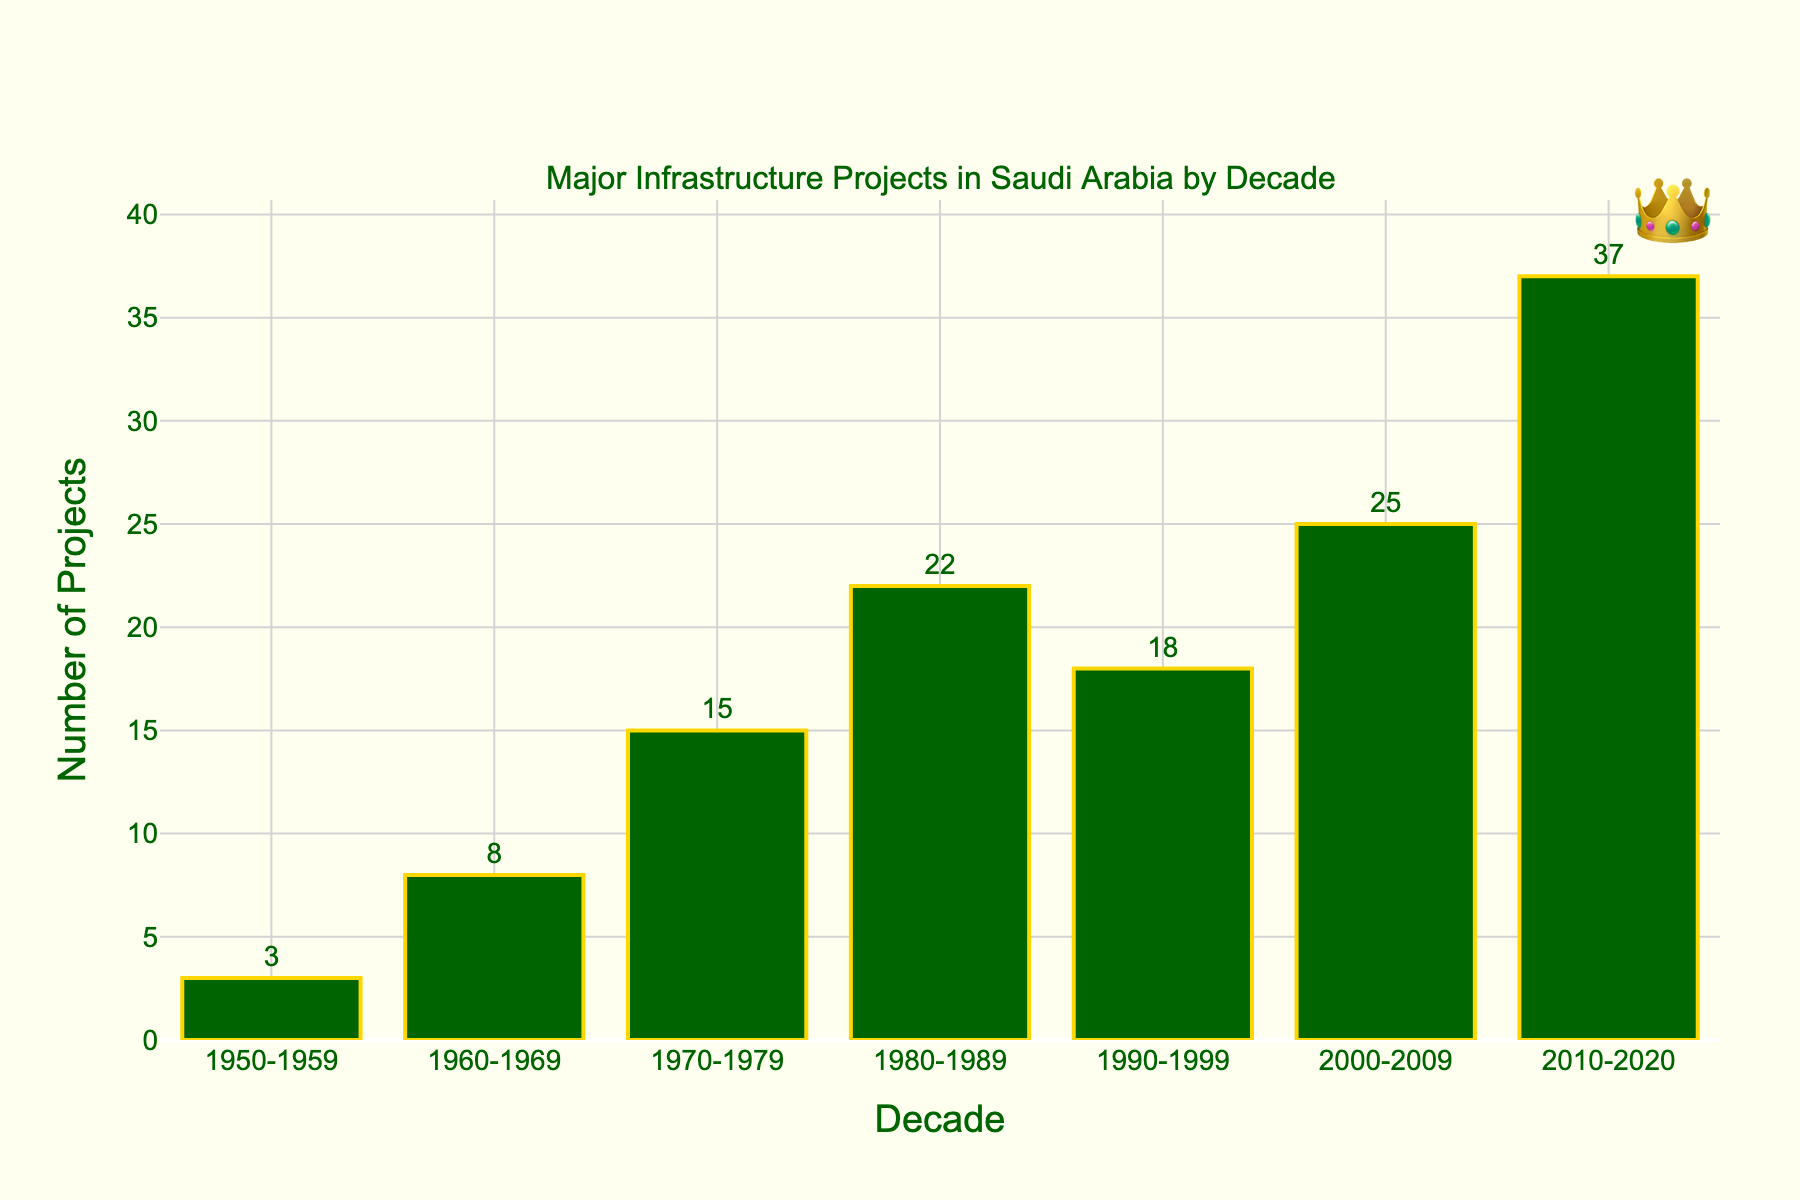Which decade had the most major infrastructure projects? The decade with the highest bar represents the most major infrastructure projects. The bar for 2010-2020 is the tallest, indicating the highest number.
Answer: 2010-2020 How many major infrastructure projects were completed in the 1980s? The y-axis value for the 1980-1989 bar represents the number of major infrastructure projects completed in that decade. The bar reaches up to 22.
Answer: 22 Compare the number of projects in the 1970s and the 1990s. The bar for 1970-1979 reaches 15 while the bar for 1990-1999 reaches 18. 18 is greater than 15, showing more projects in the 1990s.
Answer: 1990s had more projects How much did the number of projects increase from the 1950s to the 2010s? Subtract the number of projects in the 1950s (3) from the number in the 2010s (37). This subtraction gives you the increase. 37 - 3 = 34.
Answer: Increase by 34 What is the average number of projects per decade from 1950 to 2009? Sum the number of projects from each decade from 1950 to 2009, then divide by the number of decades. The sum is 3 + 8 + 15 + 22 + 18 + 25 = 91, and there are 6 decades: 91 / 6 ≈ 15.17.
Answer: 15.17 Which decade saw the largest increase in projects compared to its previous decade? Find the differences between consecutive decades and identify which is the largest. The differences are: 5 (1960s-1950s), 7 (1970s-1960s), 7 (1980s-1970s), -4 (1990s-1980s), 7 (2000s-1990s), 12 (2010s-2000s). The largest increase is 12 in the 2010s.
Answer: 2010s What is the total number of major infrastructure projects from 1950 to 2020? Sum the number of projects from each decade: 3 + 8 + 15 + 22 + 18 + 25 + 37.
Answer: 128 By how many projects did the 1980s exceed the 1970s? Subtract the number of projects in the 1970-1979 (15) from the number in 1980-1989 (22). 22 - 15 = 7.
Answer: Exceeded by 7 What visual feature highlights the most significant decade for projects? The tallest bar and the annotation (👑) placed above it, marking it as significant.
Answer: Tallest bar and annotation 